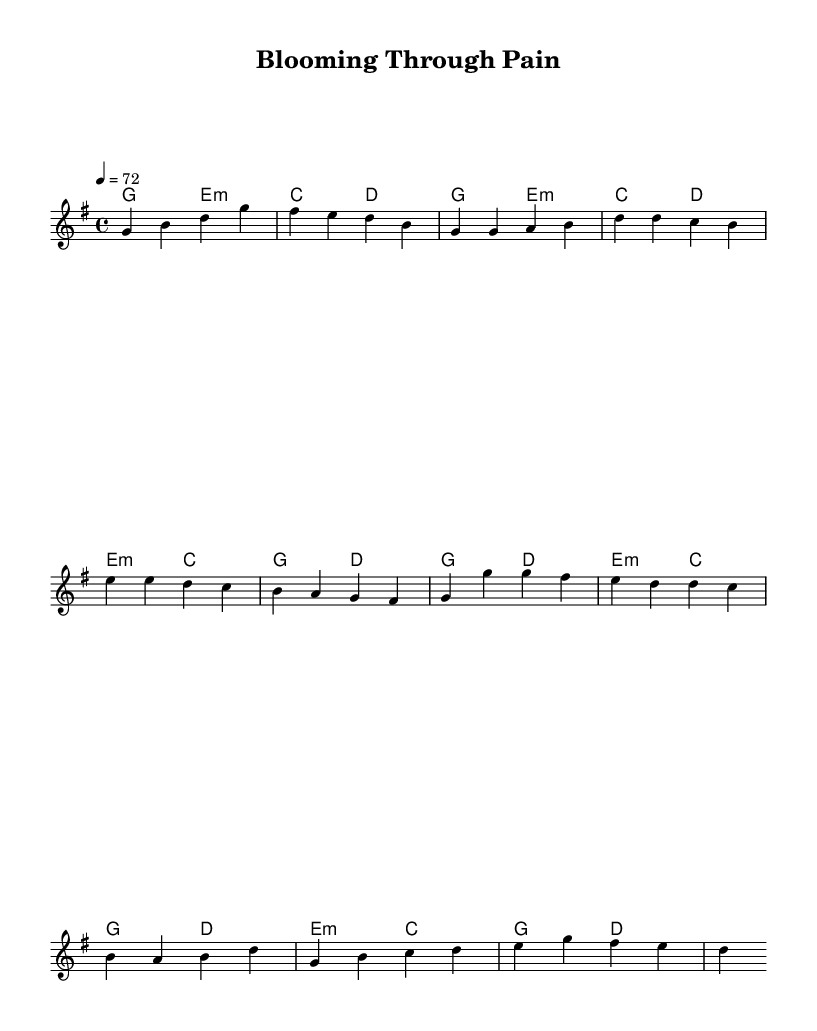What is the key signature of this music? The key signature is G major, which has one sharp (F sharp). This can be identified from the key signature notation at the beginning of the score.
Answer: G major What is the time signature of the piece? The time signature is 4/4, which indicates that there are four beats in each measure, and the quarter note receives one beat. This is shown in the time signature notation at the beginning of the score.
Answer: 4/4 What is the tempo marking indicated in the score? The tempo marking is quarter note equals 72, meaning that there are 72 beats per minute. This is stated in the tempo indication in the score.
Answer: 72 How many measures are there in the chorus section? The chorus section consists of four measures, identified by counting the sections marked by the chord changes and melody line within that part of the music.
Answer: 4 What type of chord is used in the pre-chorus section? The pre-chorus features an E minor chord followed by a C major chord, which allows for a smooth transition in emotion and supports the lyrical content common in K-Pop ballads. This is determined by looking at the chord names corresponding to that part of the score.
Answer: E minor, C major Which theme is explored in this piece? The theme explored in this piece is self-discovery, as indicated by the title "Blooming Through Pain" and the emotional context typical of K-Pop ballads that discuss personal growth.
Answer: Self-discovery 